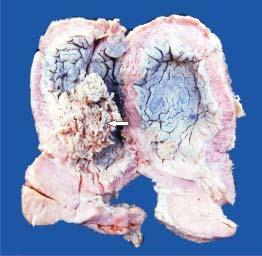what shows papillary tumour floating in the lumen?
Answer the question using a single word or phrase. Mucosal surface 